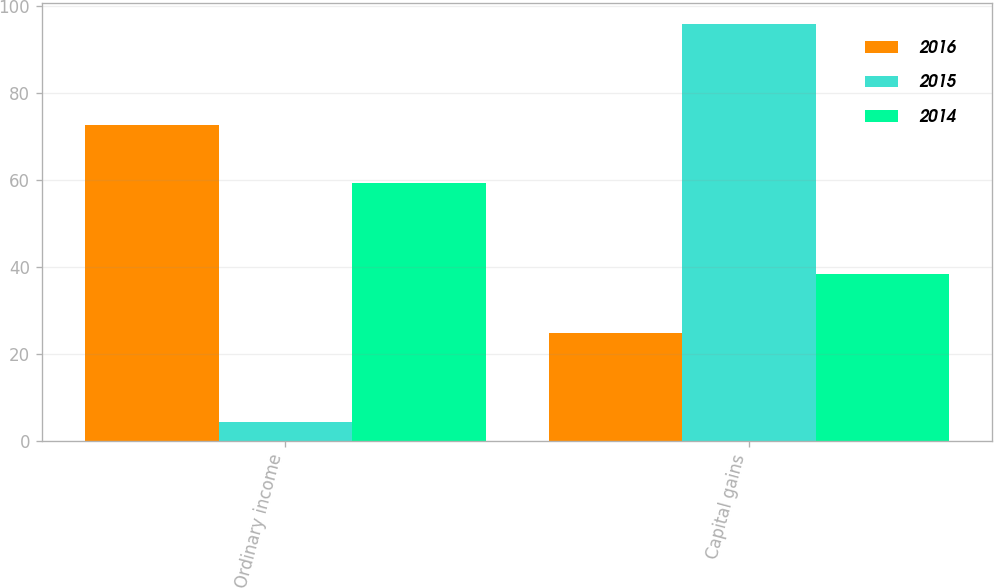<chart> <loc_0><loc_0><loc_500><loc_500><stacked_bar_chart><ecel><fcel>Ordinary income<fcel>Capital gains<nl><fcel>2016<fcel>72.6<fcel>24.8<nl><fcel>2015<fcel>4.2<fcel>95.8<nl><fcel>2014<fcel>59.2<fcel>38.3<nl></chart> 